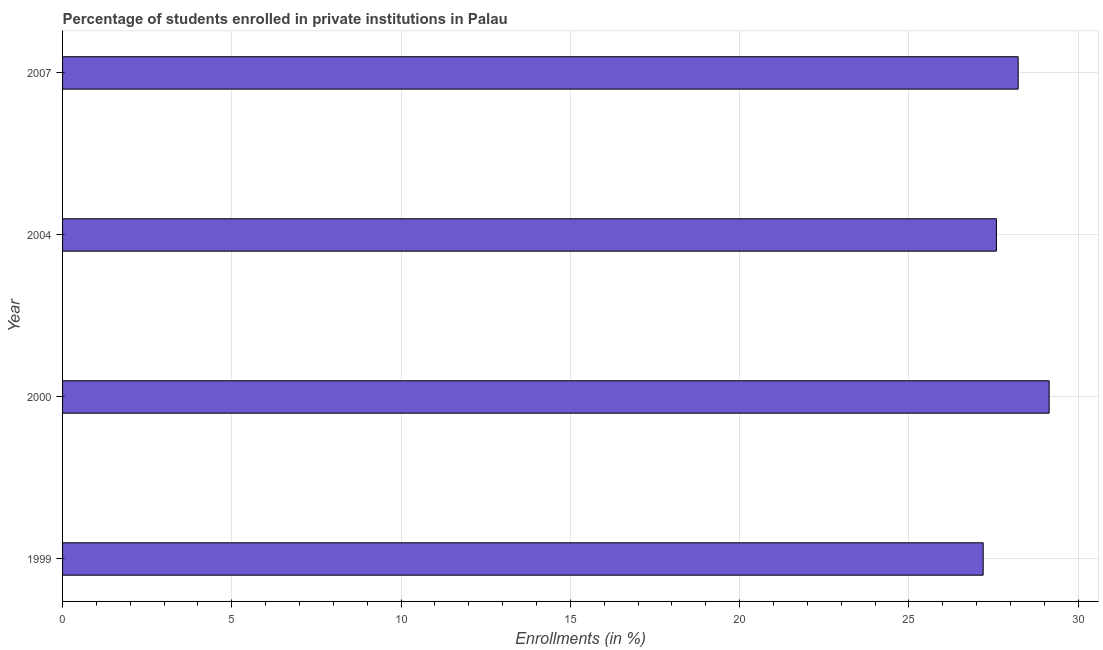Does the graph contain any zero values?
Provide a short and direct response. No. What is the title of the graph?
Your answer should be very brief. Percentage of students enrolled in private institutions in Palau. What is the label or title of the X-axis?
Offer a terse response. Enrollments (in %). What is the label or title of the Y-axis?
Your answer should be compact. Year. What is the enrollments in private institutions in 2004?
Ensure brevity in your answer.  27.58. Across all years, what is the maximum enrollments in private institutions?
Your answer should be compact. 29.14. Across all years, what is the minimum enrollments in private institutions?
Your answer should be very brief. 27.19. In which year was the enrollments in private institutions maximum?
Offer a very short reply. 2000. In which year was the enrollments in private institutions minimum?
Your answer should be very brief. 1999. What is the sum of the enrollments in private institutions?
Offer a very short reply. 112.15. What is the difference between the enrollments in private institutions in 1999 and 2007?
Your answer should be compact. -1.03. What is the average enrollments in private institutions per year?
Your response must be concise. 28.04. What is the median enrollments in private institutions?
Your response must be concise. 27.91. In how many years, is the enrollments in private institutions greater than 16 %?
Provide a short and direct response. 4. What is the ratio of the enrollments in private institutions in 2000 to that in 2007?
Your answer should be very brief. 1.03. Is the enrollments in private institutions in 2000 less than that in 2007?
Ensure brevity in your answer.  No. Is the difference between the enrollments in private institutions in 1999 and 2000 greater than the difference between any two years?
Your answer should be compact. Yes. What is the difference between the highest and the second highest enrollments in private institutions?
Offer a very short reply. 0.92. Is the sum of the enrollments in private institutions in 1999 and 2004 greater than the maximum enrollments in private institutions across all years?
Provide a short and direct response. Yes. What is the difference between the highest and the lowest enrollments in private institutions?
Offer a terse response. 1.95. How many bars are there?
Your response must be concise. 4. Are all the bars in the graph horizontal?
Your answer should be very brief. Yes. What is the difference between two consecutive major ticks on the X-axis?
Give a very brief answer. 5. Are the values on the major ticks of X-axis written in scientific E-notation?
Your answer should be very brief. No. What is the Enrollments (in %) in 1999?
Offer a very short reply. 27.19. What is the Enrollments (in %) in 2000?
Your answer should be very brief. 29.14. What is the Enrollments (in %) in 2004?
Your response must be concise. 27.58. What is the Enrollments (in %) of 2007?
Your answer should be compact. 28.23. What is the difference between the Enrollments (in %) in 1999 and 2000?
Provide a succinct answer. -1.95. What is the difference between the Enrollments (in %) in 1999 and 2004?
Keep it short and to the point. -0.39. What is the difference between the Enrollments (in %) in 1999 and 2007?
Give a very brief answer. -1.03. What is the difference between the Enrollments (in %) in 2000 and 2004?
Ensure brevity in your answer.  1.56. What is the difference between the Enrollments (in %) in 2000 and 2007?
Your response must be concise. 0.92. What is the difference between the Enrollments (in %) in 2004 and 2007?
Provide a succinct answer. -0.64. What is the ratio of the Enrollments (in %) in 1999 to that in 2000?
Provide a succinct answer. 0.93. What is the ratio of the Enrollments (in %) in 2000 to that in 2004?
Offer a terse response. 1.06. What is the ratio of the Enrollments (in %) in 2000 to that in 2007?
Offer a terse response. 1.03. What is the ratio of the Enrollments (in %) in 2004 to that in 2007?
Offer a very short reply. 0.98. 